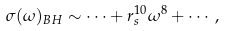<formula> <loc_0><loc_0><loc_500><loc_500>\sigma ( \omega ) _ { B H } \sim \cdots + r ^ { 1 0 } _ { s } \omega ^ { 8 } + \cdots ,</formula> 